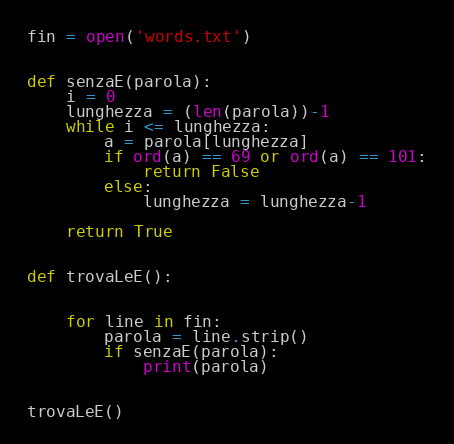Convert code to text. <code><loc_0><loc_0><loc_500><loc_500><_Python_>fin = open('words.txt')


def senzaE(parola):
    i = 0
    lunghezza = (len(parola))-1
    while i <= lunghezza:
        a = parola[lunghezza]
        if ord(a) == 69 or ord(a) == 101:
            return False
        else:
            lunghezza = lunghezza-1

    return True


def trovaLeE():


    for line in fin:
        parola = line.strip()
        if senzaE(parola):
            print(parola)


trovaLeE()</code> 